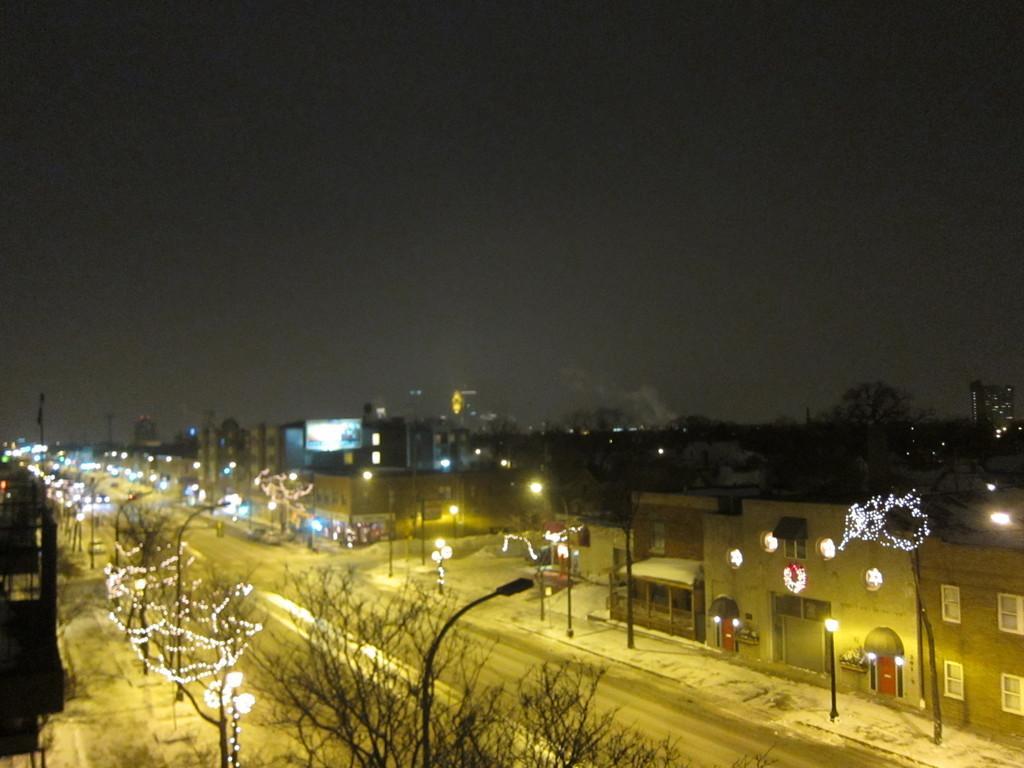In one or two sentences, can you explain what this image depicts? In this picture I can see few trees and few buildings and I can see few pole lights and I can see lights to the trees and I can see sky. 